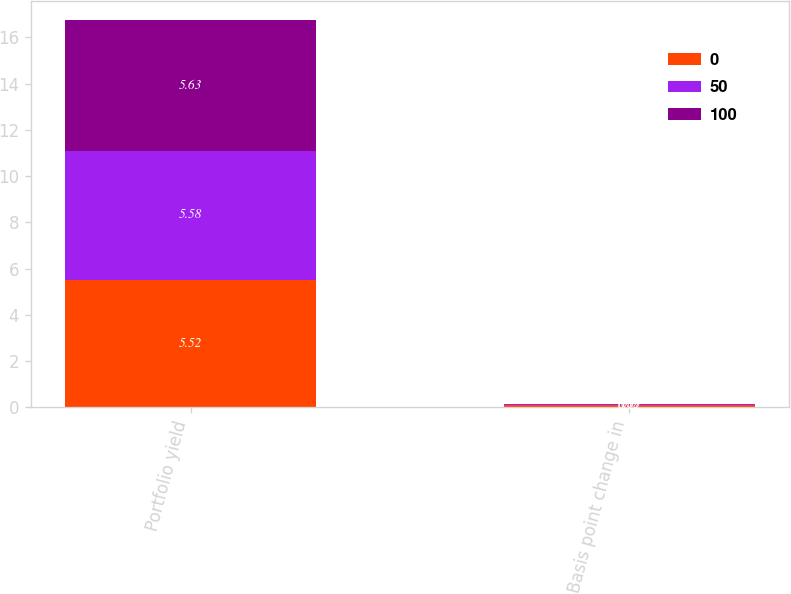Convert chart. <chart><loc_0><loc_0><loc_500><loc_500><stacked_bar_chart><ecel><fcel>Portfolio yield<fcel>Basis point change in<nl><fcel>0<fcel>5.52<fcel>0.11<nl><fcel>50<fcel>5.58<fcel>0.05<nl><fcel>100<fcel>5.63<fcel>0<nl></chart> 